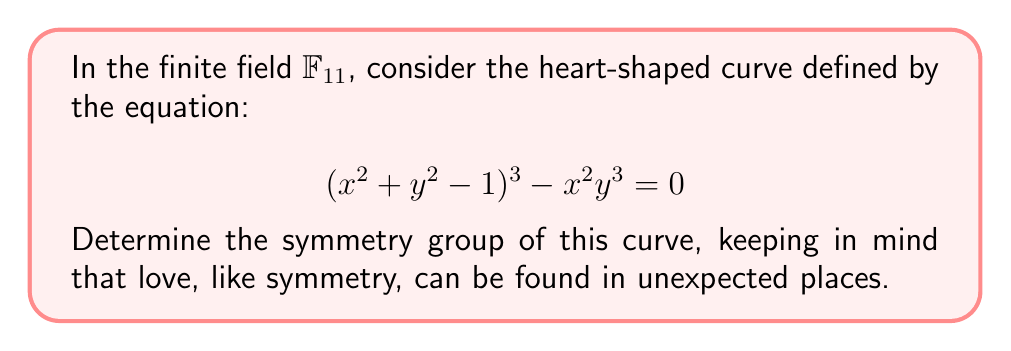Provide a solution to this math problem. To determine the symmetry group of the heart-shaped curve in $\mathbb{F}_{11}$, we follow these steps:

1) First, we need to identify the possible symmetries:
   - Reflection about the y-axis (x → -x)
   - Reflection about the x-axis (y → -y)
   - 180° rotation about the origin (x → -x, y → -y)

2) Let's check each symmetry:

   a) Reflection about y-axis:
      Substitute x with -x in the equation:
      $((-x)^2 + y^2 - 1)^3 - (-x)^2y^3 = 0$
      $(x^2 + y^2 - 1)^3 - x^2y^3 = 0$
      This is the same as the original equation, so this symmetry holds.

   b) Reflection about x-axis:
      Substitute y with -y in the equation:
      $(x^2 + (-y)^2 - 1)^3 - x^2(-y)^3 = 0$
      $(x^2 + y^2 - 1)^3 + x^2y^3 = 0$
      This is not the same as the original equation, so this symmetry does not hold.

   c) 180° rotation:
      Substitute x with -x and y with -y:
      $((-x)^2 + (-y)^2 - 1)^3 - (-x)^2(-y)^3 = 0$
      $(x^2 + y^2 - 1)^3 - x^2y^3 = 0$
      This is the same as the original equation, so this symmetry holds.

3) The symmetries that hold form a group. In this case, we have:
   - Identity transformation
   - Reflection about y-axis
   - 180° rotation

4) This group of symmetries is isomorphic to the cyclic group $C_2$ of order 2.

5) Note that working in $\mathbb{F}_{11}$ doesn't affect the symmetry group in this case, as the symmetries are preserved under modular arithmetic.
Answer: $C_2$ 